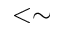Convert formula to latex. <formula><loc_0><loc_0><loc_500><loc_500>< \sim</formula> 